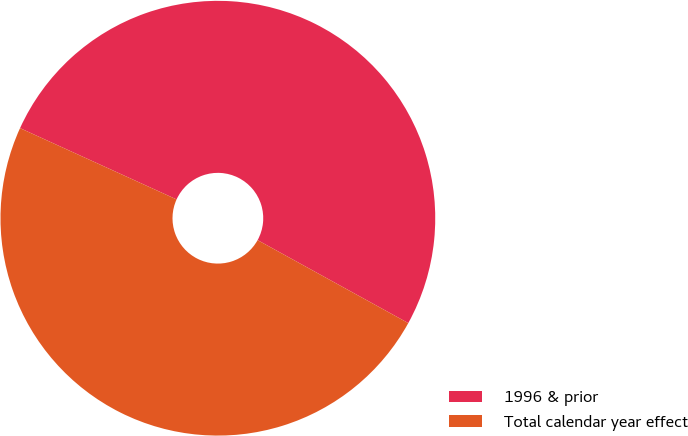<chart> <loc_0><loc_0><loc_500><loc_500><pie_chart><fcel>1996 & prior<fcel>Total calendar year effect<nl><fcel>51.21%<fcel>48.79%<nl></chart> 